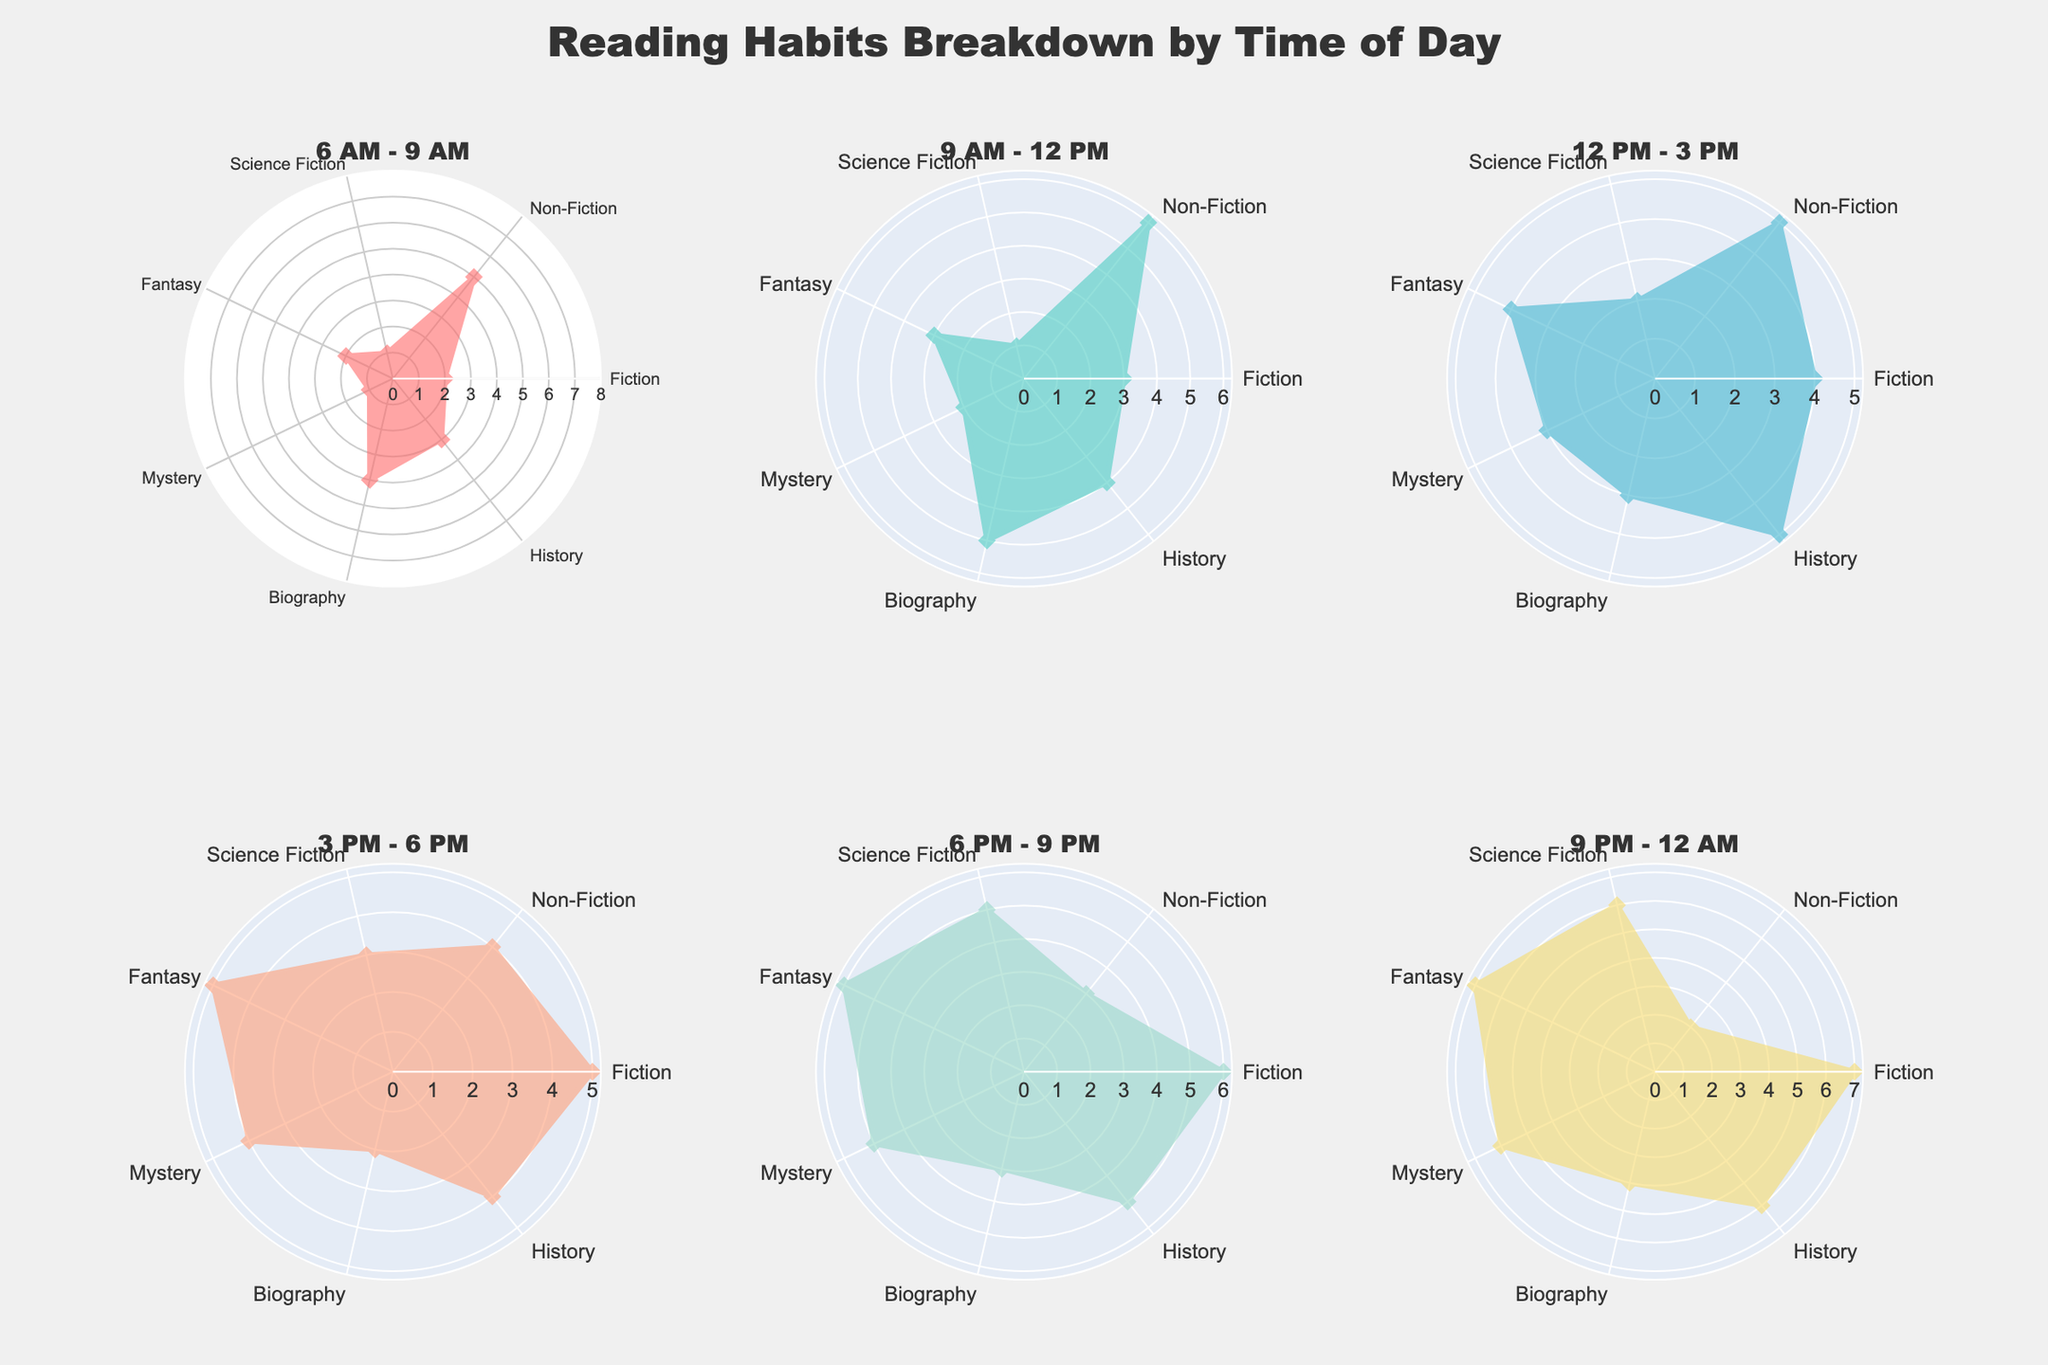What is the title of the chart? The title of the chart is prominently displayed at the top of the figure.
Answer: Reading Habits Breakdown by Time of Day Which time slot has the highest reading score for Non-Fiction? By examining the radar chart for each time slot, the time slot with the highest value for Non-Fiction is identified.
Answer: 9 AM - 12 PM What genres are read the most between 9 PM - 12 AM? By analyzing the radar chart for the 9 PM - 12 AM time slot, the genres with the highest values can be identified.
Answer: Fiction and Fantasy What is the sum of the reading scores for Mystery between 6 AM - 9 AM and 6 PM - 9 PM? Add the Mystery values for 6 AM - 9 AM (1) and 6 PM - 9 PM (5).
Answer: 6 How does the reading trend for Fiction change throughout the day? Examine the Fiction values in each time slot and observe the pattern of increase or decrease. The values are: 6 AM - 9 AM (2), 9 AM - 12 PM (3), 12 PM - 3 PM (4), 3 PM - 6 PM (5), 6 PM - 9 PM (6), and 9 PM - 12 AM (7).
Answer: Increasing Which time slot has the more balanced reading habits across all genres? Identify the time slot where the radar chart outlines a more regular, symmetrical shape, indicating balanced reading across all genres.
Answer: 12 PM - 3 PM How much more was Science Fiction read between 6 PM - 9 PM compared to 6 AM - 9 AM? Subtract the Science Fiction value for 6 AM - 9 AM (1) from the value for 6 PM - 9 PM (5).
Answer: 4 Which genre has the least variation in reading scores across the day? By examining the radar chart for each time slot, determine the genre whose values vary the least across all time slots.
Answer: History What combination of time and genre sees the highest reading score? Identify the highest value across all time slots and genres and note the corresponding time and genre.
Answer: 9 PM - 12 AM, Fiction How does the reading trend for Biography change throughout the day? Examine the Biography values in each time slot and observe the pattern of increase or decrease. The values are: 6 AM - 9 AM (4), 9 AM - 12 PM (5), 12 PM - 3 PM (3), 3 PM - 6 PM (2), 6 PM - 9 PM (3), and 9 PM - 12 AM (4).
Answer: Fluctuating 